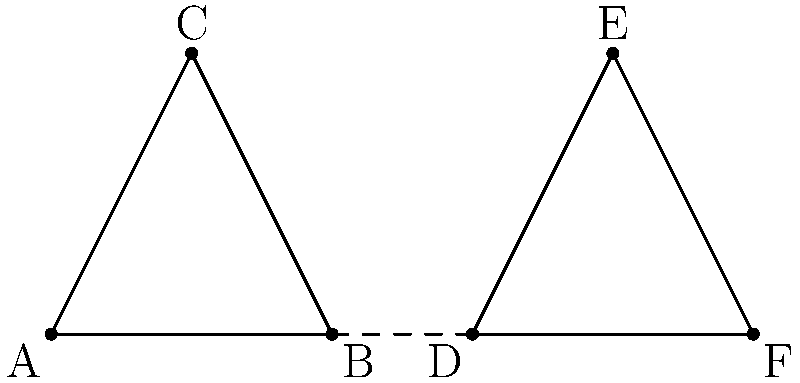A local business is designing a symmetrical logo consisting of two congruent triangles. In the diagram, triangle ABC and triangle DEF form the logo. Identify and prove which parts of the triangles are congruent to ensure the logo maintains perfect symmetry for effective branding. To prove congruence between the triangles ABC and DEF, we'll use the Side-Angle-Side (SAS) congruence theorem. Here's a step-by-step explanation:

1. Given: The logo consists of two triangles, ABC and DEF, intended to be congruent.

2. Step 1: Identify the corresponding sides
   - AB corresponds to DF
   - BC corresponds to EF
   - AC corresponds to DE

3. Step 2: Prove AB ≅ DF
   - The dashed line BD bisects the logo, creating a line of symmetry.
   - Therefore, AB = DF (reflection across the line of symmetry)

4. Step 3: Prove ∠BAC ≅ ∠FDE
   - The line of symmetry BD ensures that ∠BAC = ∠FDE (reflection across the line of symmetry)

5. Step 4: Prove AC ≅ DE
   - The line of symmetry BD ensures that AC = DE (reflection across the line of symmetry)

6. Step 5: Apply SAS Congruence Theorem
   - We have proven that:
     a) AB ≅ DF (side)
     b) ∠BAC ≅ ∠FDE (angle)
     c) AC ≅ DE (side)
   - By the SAS Congruence Theorem, triangle ABC ≅ triangle DEF

7. Conclusion: Since the triangles are congruent, all corresponding parts are congruent:
   - AB ≅ DF, BC ≅ EF, AC ≅ DE (all sides)
   - ∠BAC ≅ ∠FDE, ∠ABC ≅ ∠DEF, ∠BCA ≅ ∠EFD (all angles)
Answer: AB ≅ DF, BC ≅ EF, AC ≅ DE, ∠BAC ≅ ∠FDE, ∠ABC ≅ ∠DEF, ∠BCA ≅ ∠EFD 